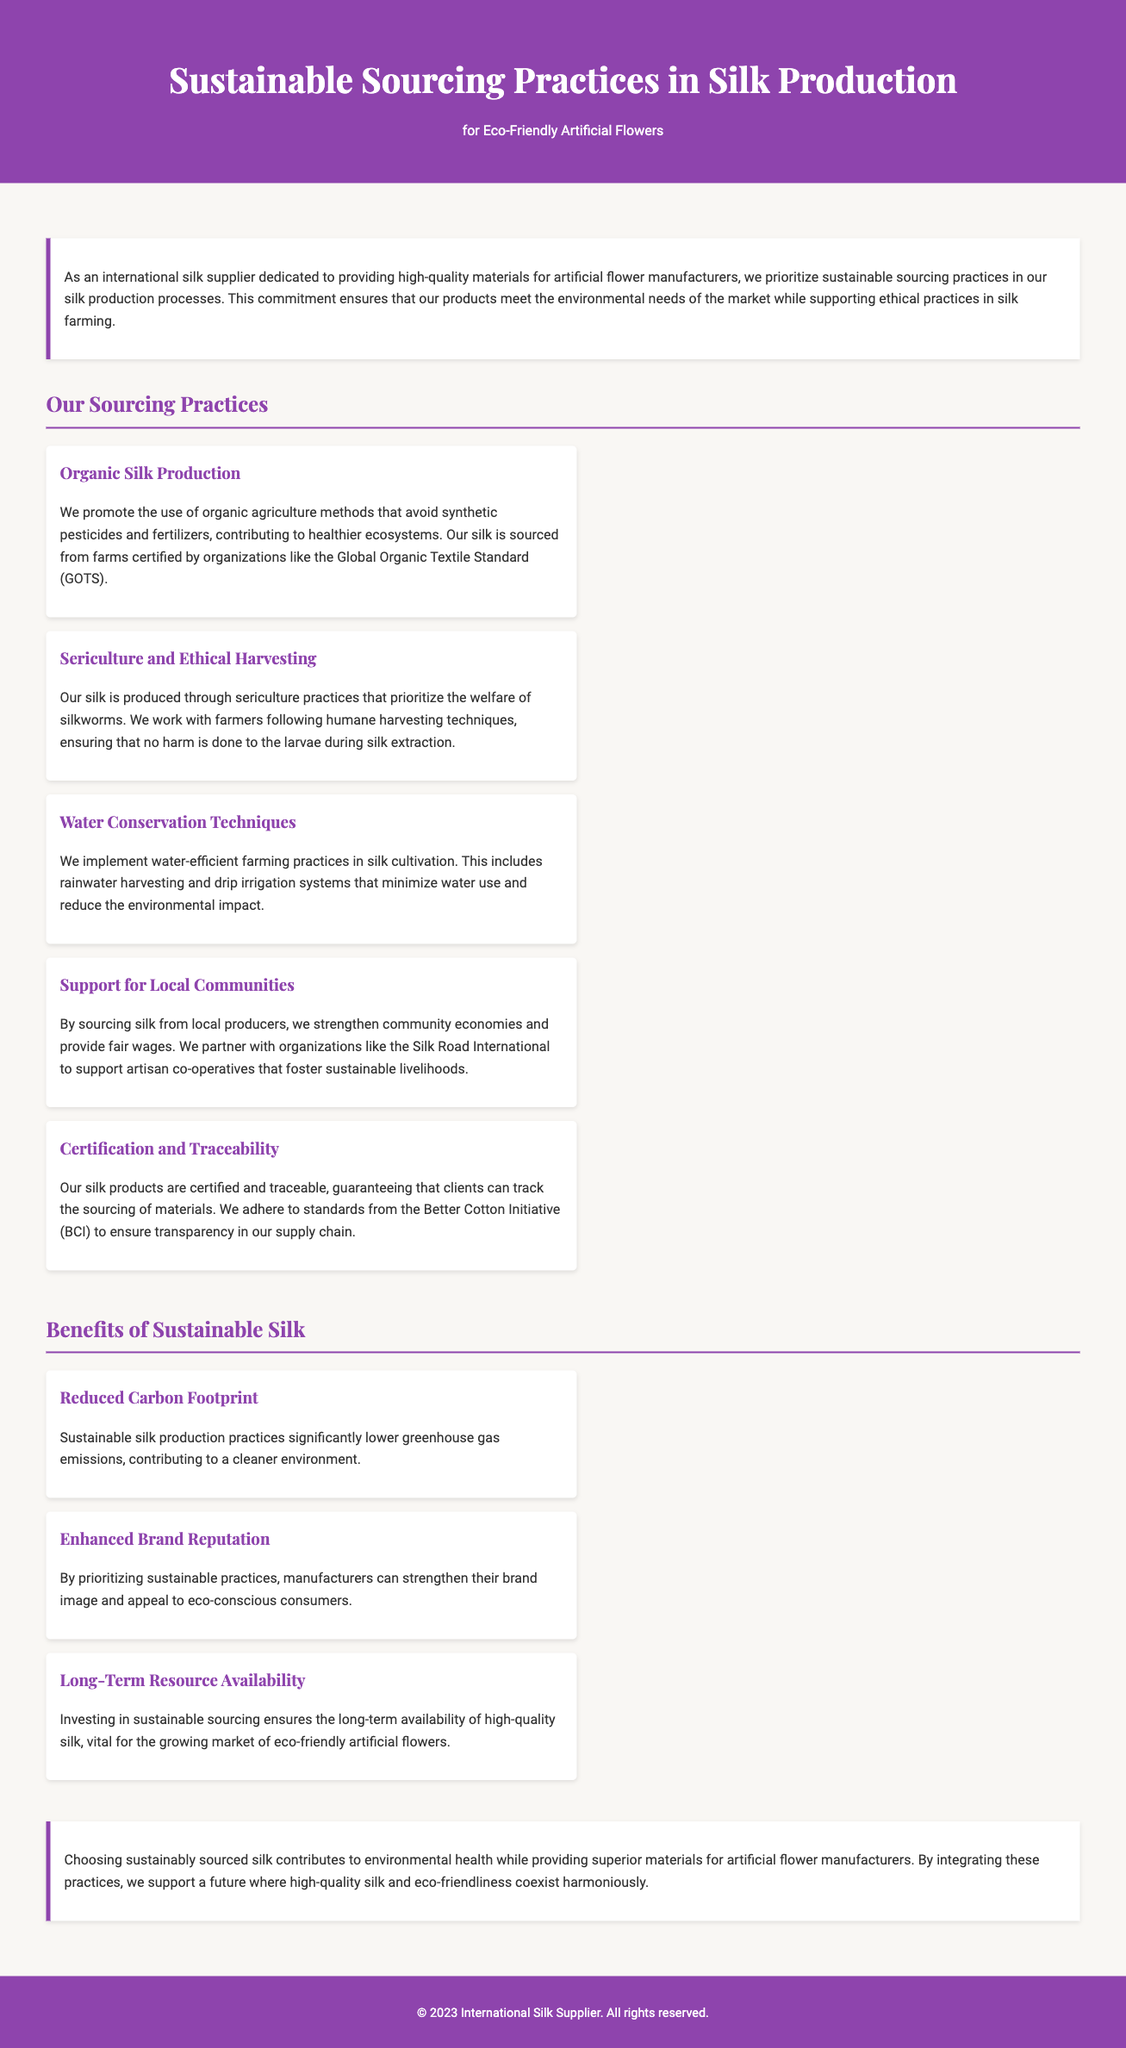What is the primary focus of the catalog? The primary focus of the catalog is on sustainable sourcing practices in silk production for eco-friendly artificial flowers.
Answer: Sustainable sourcing practices What organization certifies organic silk farms? The organization that certifies organic silk farms is mentioned in the document, highlighting adherence to specific agricultural standards.
Answer: Global Organic Textile Standard (GOTS) What technique is emphasized for water conservation? The document lists specific practices used in silk cultivation that promote efficient water use, particularly emphasizing one technique.
Answer: Drip irrigation systems Who benefits from the support for local communities? The catalog discusses the economic impacts of sourcing silk from local producers, particularly mentioning a specific group that enjoys benefits.
Answer: Local producers What aspect does sustainable silk production significantly lower? One of the benefits described in the document is the reduction of a specific environmental issue through sustainable practices.
Answer: Greenhouse gas emissions What initiative ensures transparency in the silk supply chain? The document mentions a specific initiative designed to provide traceability and certification for silk products to guarantee sourcing.
Answer: Better Cotton Initiative (BCI) How does sustainable silk impact brand reputation? The document highlights the influence of sustainable practices on how brands are perceived in the market, particularly among a specific consumer demographic.
Answer: Eco-conscious consumers What is the conclusion regarding the future of silk? The document wraps up by emphasizing a harmonious relationship between two important aspects of silk production and market demand.
Answer: Eco-friendliness and high-quality silk 